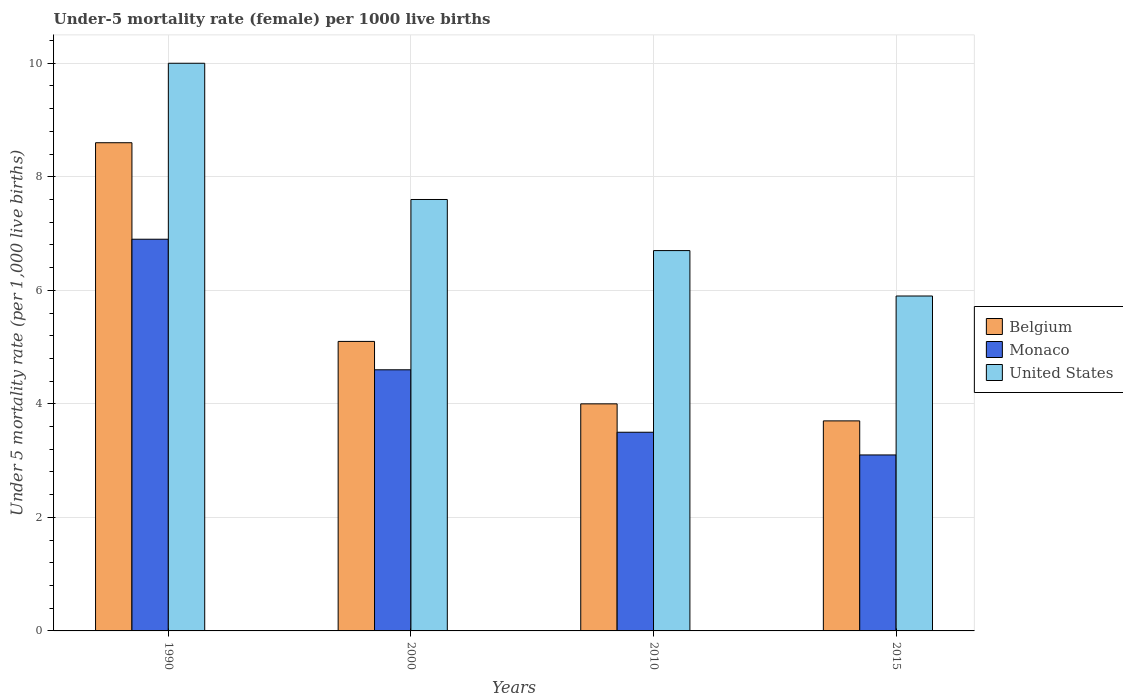Are the number of bars per tick equal to the number of legend labels?
Offer a very short reply. Yes. How many bars are there on the 4th tick from the left?
Keep it short and to the point. 3. How many bars are there on the 2nd tick from the right?
Provide a succinct answer. 3. What is the label of the 1st group of bars from the left?
Provide a succinct answer. 1990. What is the under-five mortality rate in Monaco in 1990?
Offer a terse response. 6.9. In which year was the under-five mortality rate in United States minimum?
Ensure brevity in your answer.  2015. What is the total under-five mortality rate in Belgium in the graph?
Your answer should be very brief. 21.4. What is the difference between the under-five mortality rate in Monaco in 1990 and that in 2000?
Offer a very short reply. 2.3. What is the difference between the under-five mortality rate in Belgium in 2000 and the under-five mortality rate in Monaco in 2015?
Keep it short and to the point. 2. What is the average under-five mortality rate in Belgium per year?
Provide a succinct answer. 5.35. In the year 2015, what is the difference between the under-five mortality rate in Belgium and under-five mortality rate in Monaco?
Offer a terse response. 0.6. What is the ratio of the under-five mortality rate in Monaco in 1990 to that in 2010?
Keep it short and to the point. 1.97. Is the difference between the under-five mortality rate in Belgium in 2010 and 2015 greater than the difference between the under-five mortality rate in Monaco in 2010 and 2015?
Offer a terse response. No. What is the difference between the highest and the lowest under-five mortality rate in Belgium?
Your answer should be compact. 4.9. In how many years, is the under-five mortality rate in United States greater than the average under-five mortality rate in United States taken over all years?
Keep it short and to the point. 2. Is the sum of the under-five mortality rate in Belgium in 2000 and 2010 greater than the maximum under-five mortality rate in United States across all years?
Make the answer very short. No. What does the 1st bar from the left in 2000 represents?
Provide a short and direct response. Belgium. What does the 2nd bar from the right in 1990 represents?
Your response must be concise. Monaco. How many bars are there?
Make the answer very short. 12. How many years are there in the graph?
Provide a succinct answer. 4. What is the difference between two consecutive major ticks on the Y-axis?
Provide a short and direct response. 2. Does the graph contain any zero values?
Ensure brevity in your answer.  No. Where does the legend appear in the graph?
Give a very brief answer. Center right. How many legend labels are there?
Provide a short and direct response. 3. What is the title of the graph?
Your answer should be very brief. Under-5 mortality rate (female) per 1000 live births. What is the label or title of the X-axis?
Provide a short and direct response. Years. What is the label or title of the Y-axis?
Your answer should be very brief. Under 5 mortality rate (per 1,0 live births). What is the Under 5 mortality rate (per 1,000 live births) of Belgium in 2000?
Provide a succinct answer. 5.1. What is the Under 5 mortality rate (per 1,000 live births) of Belgium in 2010?
Offer a very short reply. 4. What is the Under 5 mortality rate (per 1,000 live births) in Monaco in 2010?
Keep it short and to the point. 3.5. What is the Under 5 mortality rate (per 1,000 live births) of United States in 2010?
Make the answer very short. 6.7. What is the Under 5 mortality rate (per 1,000 live births) in United States in 2015?
Your answer should be very brief. 5.9. Across all years, what is the maximum Under 5 mortality rate (per 1,000 live births) in Belgium?
Provide a succinct answer. 8.6. Across all years, what is the maximum Under 5 mortality rate (per 1,000 live births) of Monaco?
Offer a very short reply. 6.9. Across all years, what is the maximum Under 5 mortality rate (per 1,000 live births) of United States?
Your response must be concise. 10. Across all years, what is the minimum Under 5 mortality rate (per 1,000 live births) in United States?
Offer a very short reply. 5.9. What is the total Under 5 mortality rate (per 1,000 live births) of Belgium in the graph?
Offer a very short reply. 21.4. What is the total Under 5 mortality rate (per 1,000 live births) of United States in the graph?
Make the answer very short. 30.2. What is the difference between the Under 5 mortality rate (per 1,000 live births) of Belgium in 1990 and that in 2000?
Keep it short and to the point. 3.5. What is the difference between the Under 5 mortality rate (per 1,000 live births) in Belgium in 1990 and that in 2010?
Offer a very short reply. 4.6. What is the difference between the Under 5 mortality rate (per 1,000 live births) of United States in 1990 and that in 2010?
Keep it short and to the point. 3.3. What is the difference between the Under 5 mortality rate (per 1,000 live births) in Belgium in 1990 and that in 2015?
Make the answer very short. 4.9. What is the difference between the Under 5 mortality rate (per 1,000 live births) in Belgium in 2000 and that in 2010?
Offer a terse response. 1.1. What is the difference between the Under 5 mortality rate (per 1,000 live births) of Monaco in 2000 and that in 2010?
Your answer should be compact. 1.1. What is the difference between the Under 5 mortality rate (per 1,000 live births) in United States in 2000 and that in 2010?
Give a very brief answer. 0.9. What is the difference between the Under 5 mortality rate (per 1,000 live births) in Belgium in 2000 and that in 2015?
Provide a short and direct response. 1.4. What is the difference between the Under 5 mortality rate (per 1,000 live births) in United States in 2000 and that in 2015?
Keep it short and to the point. 1.7. What is the difference between the Under 5 mortality rate (per 1,000 live births) in Belgium in 1990 and the Under 5 mortality rate (per 1,000 live births) in Monaco in 2000?
Keep it short and to the point. 4. What is the difference between the Under 5 mortality rate (per 1,000 live births) of Belgium in 1990 and the Under 5 mortality rate (per 1,000 live births) of United States in 2000?
Ensure brevity in your answer.  1. What is the difference between the Under 5 mortality rate (per 1,000 live births) in Belgium in 1990 and the Under 5 mortality rate (per 1,000 live births) in United States in 2010?
Keep it short and to the point. 1.9. What is the difference between the Under 5 mortality rate (per 1,000 live births) in Monaco in 1990 and the Under 5 mortality rate (per 1,000 live births) in United States in 2015?
Provide a succinct answer. 1. What is the difference between the Under 5 mortality rate (per 1,000 live births) of Belgium in 2000 and the Under 5 mortality rate (per 1,000 live births) of Monaco in 2010?
Provide a short and direct response. 1.6. What is the difference between the Under 5 mortality rate (per 1,000 live births) in Belgium in 2000 and the Under 5 mortality rate (per 1,000 live births) in United States in 2010?
Provide a short and direct response. -1.6. What is the difference between the Under 5 mortality rate (per 1,000 live births) of Monaco in 2000 and the Under 5 mortality rate (per 1,000 live births) of United States in 2010?
Keep it short and to the point. -2.1. What is the difference between the Under 5 mortality rate (per 1,000 live births) of Belgium in 2000 and the Under 5 mortality rate (per 1,000 live births) of Monaco in 2015?
Offer a terse response. 2. What is the difference between the Under 5 mortality rate (per 1,000 live births) of Belgium in 2000 and the Under 5 mortality rate (per 1,000 live births) of United States in 2015?
Your answer should be compact. -0.8. What is the difference between the Under 5 mortality rate (per 1,000 live births) of Monaco in 2000 and the Under 5 mortality rate (per 1,000 live births) of United States in 2015?
Ensure brevity in your answer.  -1.3. What is the difference between the Under 5 mortality rate (per 1,000 live births) of Belgium in 2010 and the Under 5 mortality rate (per 1,000 live births) of United States in 2015?
Give a very brief answer. -1.9. What is the difference between the Under 5 mortality rate (per 1,000 live births) in Monaco in 2010 and the Under 5 mortality rate (per 1,000 live births) in United States in 2015?
Give a very brief answer. -2.4. What is the average Under 5 mortality rate (per 1,000 live births) in Belgium per year?
Your response must be concise. 5.35. What is the average Under 5 mortality rate (per 1,000 live births) of Monaco per year?
Give a very brief answer. 4.53. What is the average Under 5 mortality rate (per 1,000 live births) in United States per year?
Your answer should be very brief. 7.55. In the year 1990, what is the difference between the Under 5 mortality rate (per 1,000 live births) in Monaco and Under 5 mortality rate (per 1,000 live births) in United States?
Your answer should be compact. -3.1. In the year 2000, what is the difference between the Under 5 mortality rate (per 1,000 live births) in Belgium and Under 5 mortality rate (per 1,000 live births) in Monaco?
Make the answer very short. 0.5. In the year 2010, what is the difference between the Under 5 mortality rate (per 1,000 live births) of Monaco and Under 5 mortality rate (per 1,000 live births) of United States?
Your response must be concise. -3.2. In the year 2015, what is the difference between the Under 5 mortality rate (per 1,000 live births) in Belgium and Under 5 mortality rate (per 1,000 live births) in Monaco?
Your response must be concise. 0.6. In the year 2015, what is the difference between the Under 5 mortality rate (per 1,000 live births) in Belgium and Under 5 mortality rate (per 1,000 live births) in United States?
Offer a terse response. -2.2. What is the ratio of the Under 5 mortality rate (per 1,000 live births) in Belgium in 1990 to that in 2000?
Give a very brief answer. 1.69. What is the ratio of the Under 5 mortality rate (per 1,000 live births) in Monaco in 1990 to that in 2000?
Provide a short and direct response. 1.5. What is the ratio of the Under 5 mortality rate (per 1,000 live births) in United States in 1990 to that in 2000?
Your answer should be compact. 1.32. What is the ratio of the Under 5 mortality rate (per 1,000 live births) in Belgium in 1990 to that in 2010?
Offer a very short reply. 2.15. What is the ratio of the Under 5 mortality rate (per 1,000 live births) in Monaco in 1990 to that in 2010?
Give a very brief answer. 1.97. What is the ratio of the Under 5 mortality rate (per 1,000 live births) of United States in 1990 to that in 2010?
Offer a very short reply. 1.49. What is the ratio of the Under 5 mortality rate (per 1,000 live births) in Belgium in 1990 to that in 2015?
Keep it short and to the point. 2.32. What is the ratio of the Under 5 mortality rate (per 1,000 live births) in Monaco in 1990 to that in 2015?
Make the answer very short. 2.23. What is the ratio of the Under 5 mortality rate (per 1,000 live births) of United States in 1990 to that in 2015?
Your answer should be very brief. 1.69. What is the ratio of the Under 5 mortality rate (per 1,000 live births) of Belgium in 2000 to that in 2010?
Offer a terse response. 1.27. What is the ratio of the Under 5 mortality rate (per 1,000 live births) of Monaco in 2000 to that in 2010?
Your response must be concise. 1.31. What is the ratio of the Under 5 mortality rate (per 1,000 live births) in United States in 2000 to that in 2010?
Offer a terse response. 1.13. What is the ratio of the Under 5 mortality rate (per 1,000 live births) in Belgium in 2000 to that in 2015?
Keep it short and to the point. 1.38. What is the ratio of the Under 5 mortality rate (per 1,000 live births) of Monaco in 2000 to that in 2015?
Keep it short and to the point. 1.48. What is the ratio of the Under 5 mortality rate (per 1,000 live births) of United States in 2000 to that in 2015?
Provide a succinct answer. 1.29. What is the ratio of the Under 5 mortality rate (per 1,000 live births) in Belgium in 2010 to that in 2015?
Give a very brief answer. 1.08. What is the ratio of the Under 5 mortality rate (per 1,000 live births) of Monaco in 2010 to that in 2015?
Provide a succinct answer. 1.13. What is the ratio of the Under 5 mortality rate (per 1,000 live births) of United States in 2010 to that in 2015?
Ensure brevity in your answer.  1.14. What is the difference between the highest and the second highest Under 5 mortality rate (per 1,000 live births) in Monaco?
Provide a short and direct response. 2.3. 